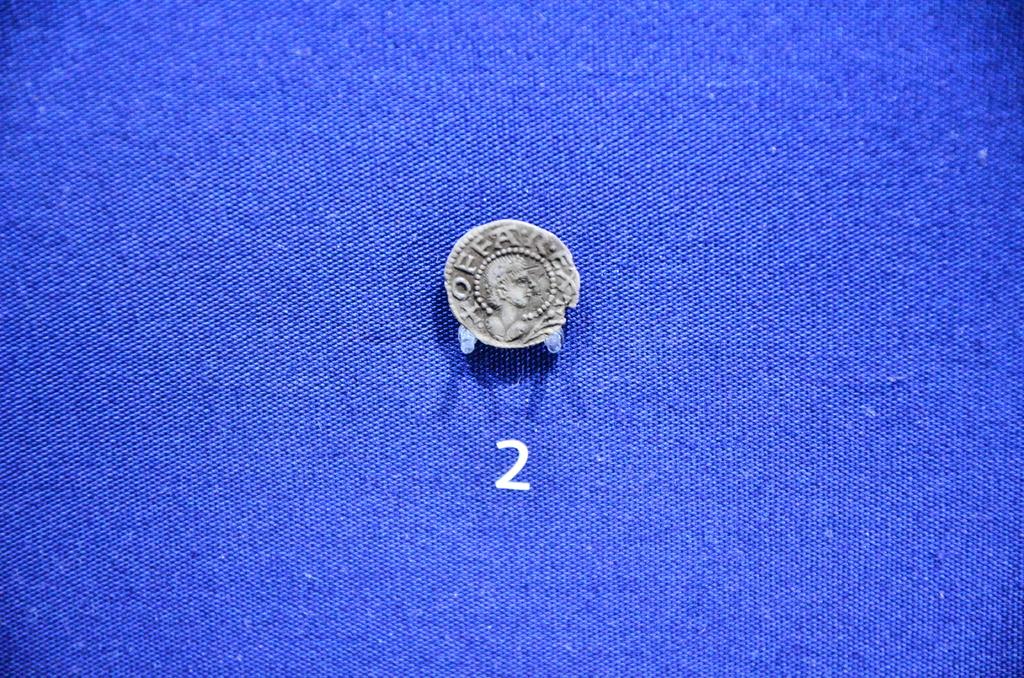What number is below the coin?
Your response must be concise. 2. What does the coin say?
Ensure brevity in your answer.  Offa rex. 